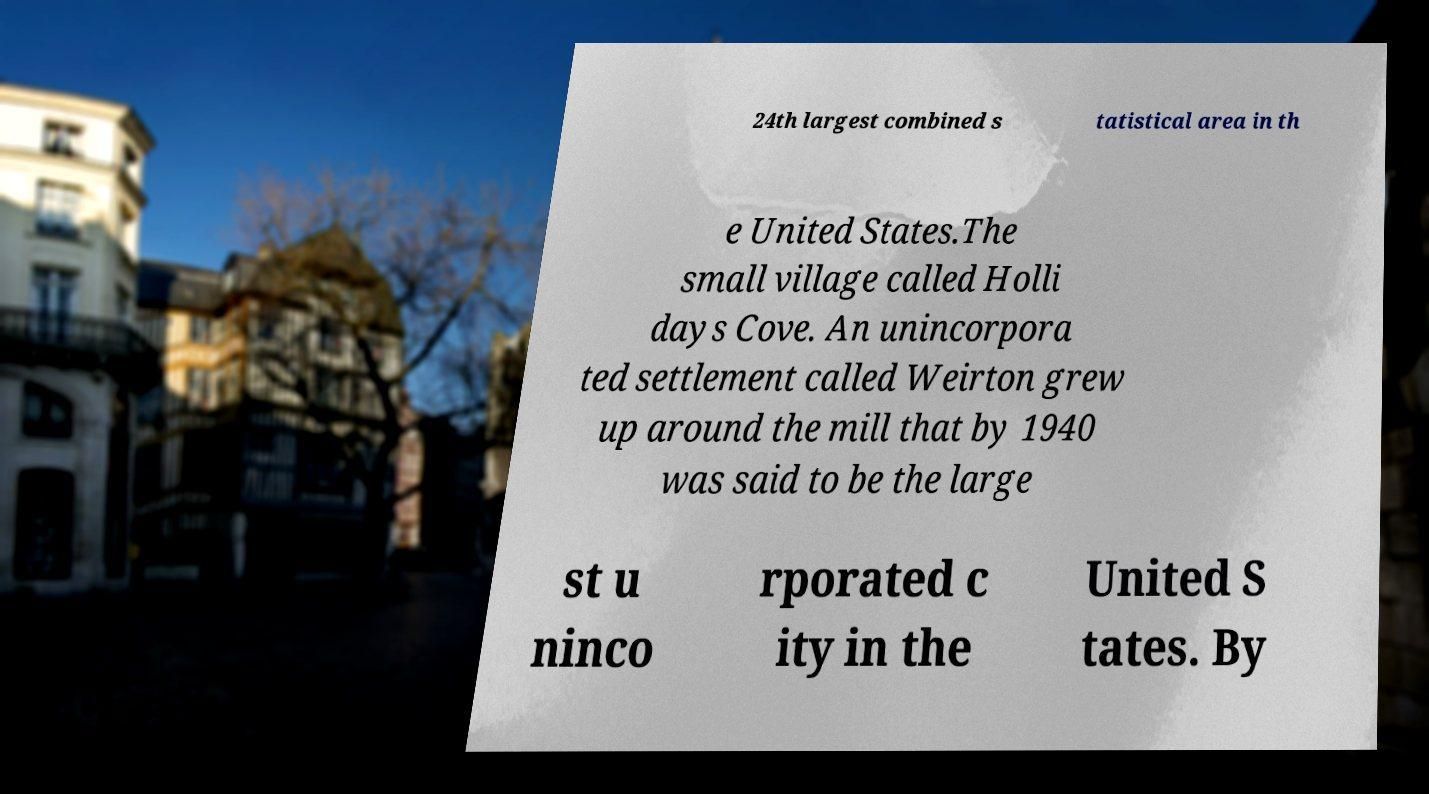Can you accurately transcribe the text from the provided image for me? 24th largest combined s tatistical area in th e United States.The small village called Holli days Cove. An unincorpora ted settlement called Weirton grew up around the mill that by 1940 was said to be the large st u ninco rporated c ity in the United S tates. By 